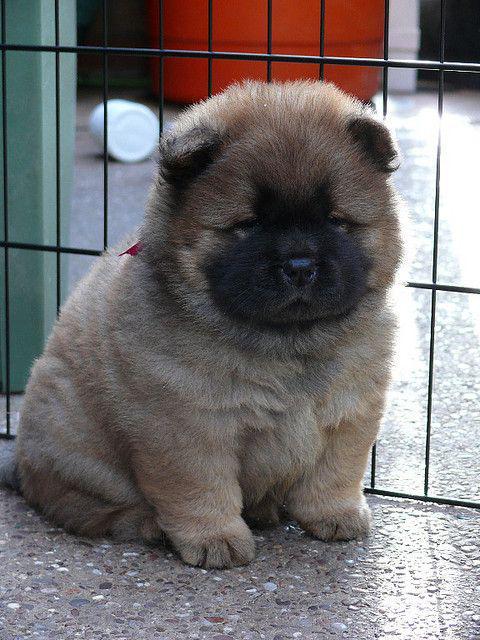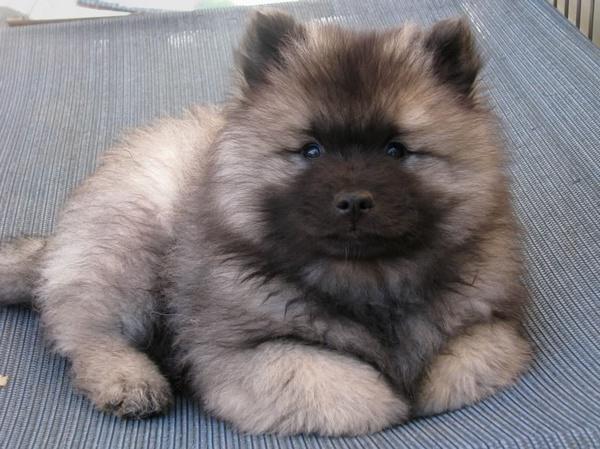The first image is the image on the left, the second image is the image on the right. Evaluate the accuracy of this statement regarding the images: "A total of three dogs are shown in the foreground of the combined images.". Is it true? Answer yes or no. No. The first image is the image on the left, the second image is the image on the right. Analyze the images presented: Is the assertion "One of the dogs is standing and looking toward the camera." valid? Answer yes or no. No. 